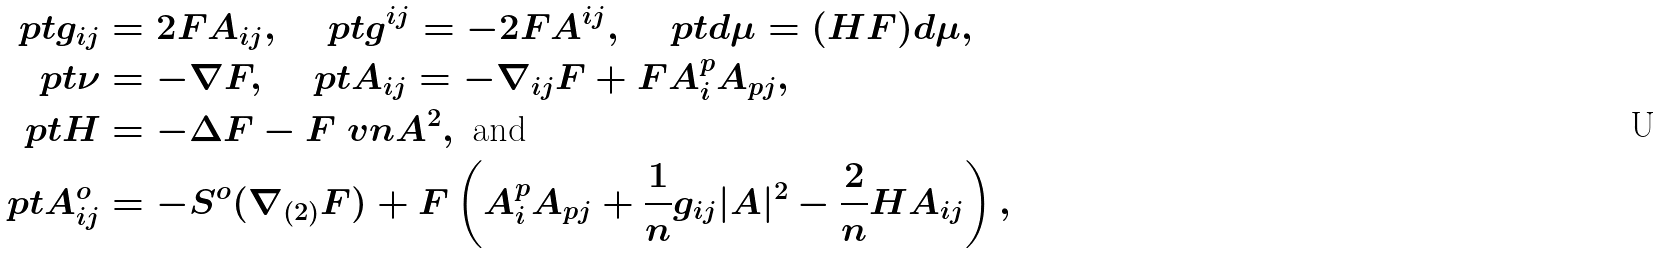<formula> <loc_0><loc_0><loc_500><loc_500>\ p { t } g _ { i j } & = 2 F A _ { i j } , \quad \ p { t } g ^ { i j } = - 2 F A ^ { i j } , \quad \ p { t } d \mu = ( H F ) d \mu , \\ \ p { t } \nu & = - \nabla F , \quad \ p { t } A _ { i j } = - \nabla _ { i j } F + F A _ { i } ^ { p } A _ { p j } , \\ \ p { t } H & = - \Delta F - F \ v n { A } ^ { 2 } , \text { and } \\ \ p { t } A ^ { o } _ { i j } & = - S ^ { o } ( \nabla _ { ( 2 ) } F ) + F \left ( A _ { i } ^ { p } A _ { p j } + \frac { 1 } { n } g _ { i j } | A | ^ { 2 } - \frac { 2 } { n } H A _ { i j } \right ) ,</formula> 